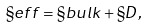Convert formula to latex. <formula><loc_0><loc_0><loc_500><loc_500>\S { e f f } = \S { b u l k } + \S { D } ,</formula> 